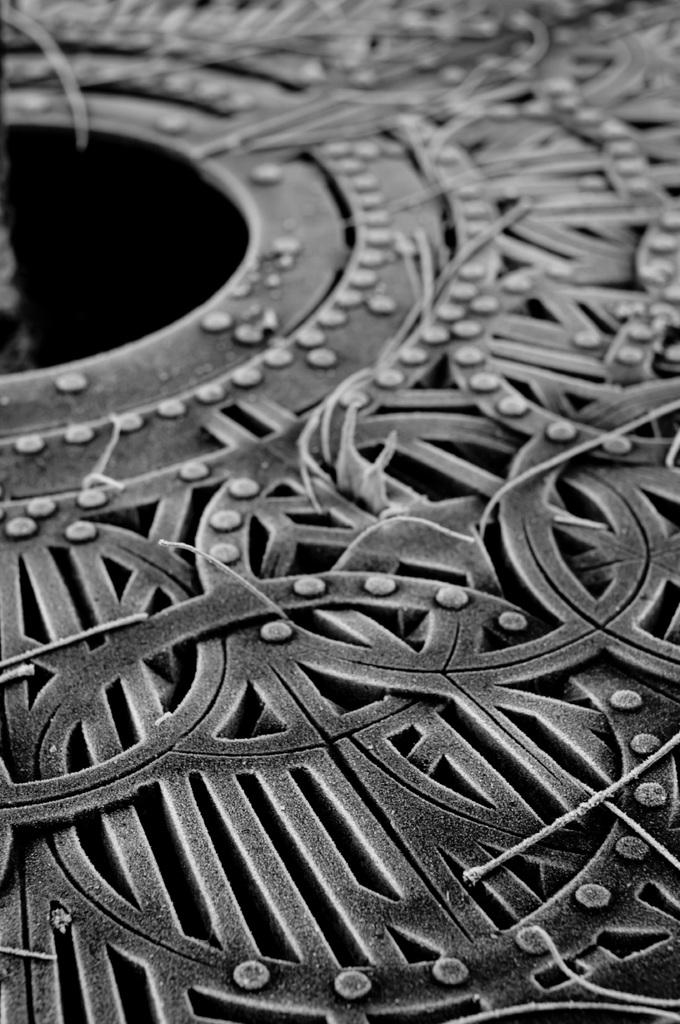What shape is the main object in the image? The main object in the image is a round metal part. What can be observed on the surface of the round metal part? The round metal part has designs on it. Where is the flock of birds flying in the image? There are no birds or flocks present in the image; it only features a round metal part with designs on it. 